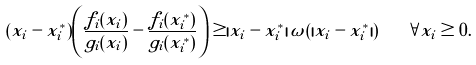<formula> <loc_0><loc_0><loc_500><loc_500>( x _ { i } - x _ { i } ^ { * } ) \left ( \frac { f _ { i } ( x _ { i } ) } { g _ { i } ( x _ { i } ) } - \frac { f _ { i } ( x ^ { * } _ { i } ) } { g _ { i } ( x ^ { * } _ { i } ) } \right ) \geq | x _ { i } - x ^ { * } _ { i } | \, \omega ( | x _ { i } - x ^ { * } _ { i } | ) \quad \forall x _ { i } \geq 0 .</formula> 